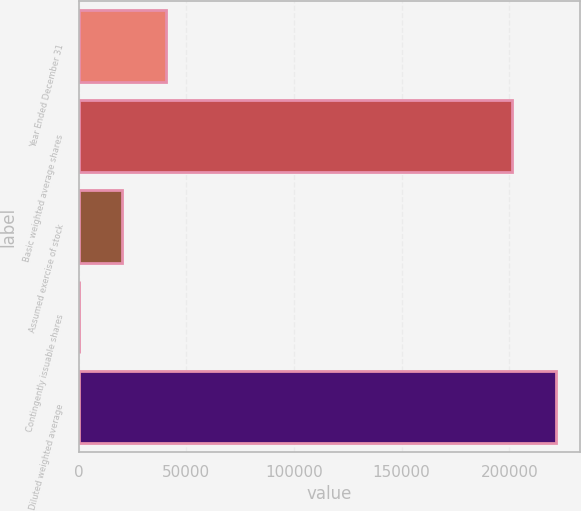<chart> <loc_0><loc_0><loc_500><loc_500><bar_chart><fcel>Year Ended December 31<fcel>Basic weighted average shares<fcel>Assumed exercise of stock<fcel>Contingently issuable shares<fcel>Diluted weighted average<nl><fcel>40592.8<fcel>201357<fcel>20310.4<fcel>28<fcel>221639<nl></chart> 